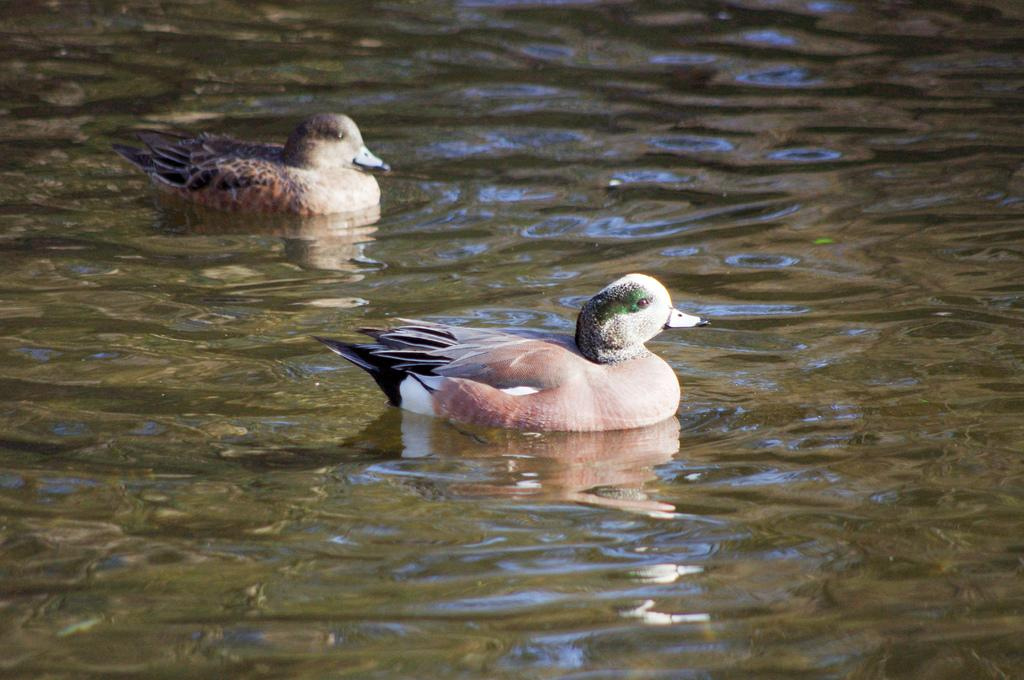What type of animals can be seen in the image? There are birds in the image. What body of water is present in the image? There is a lake in the image. What can be observed on the water surface? There are reflections on the water surface. What knowledge can be gained from touching the birds in the image? There is no need to touch the birds in the image to gain knowledge, and touching them would not be advisable. 